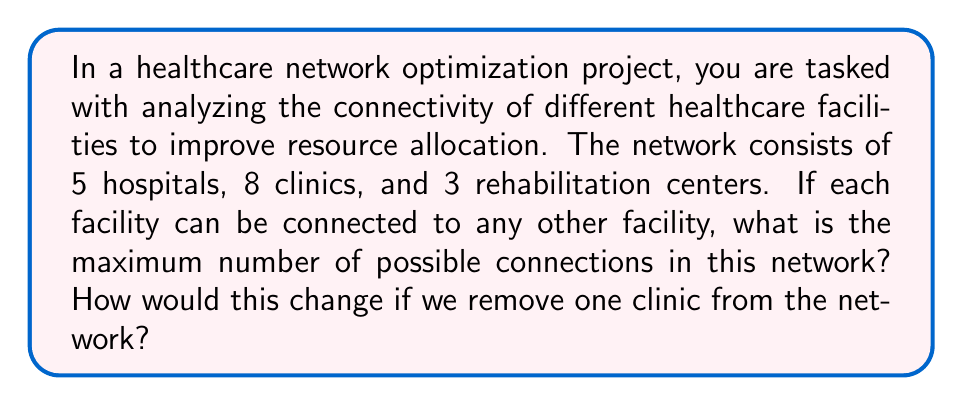Show me your answer to this math problem. To solve this problem, we'll use concepts from graph theory in topology.

1. First, let's calculate the total number of facilities:
   $5 + 8 + 3 = 16$ facilities

2. In a fully connected network, each facility can connect to every other facility except itself. The formula for the maximum number of connections in a network with $n$ nodes is:

   $$\frac{n(n-1)}{2}$$

3. Plugging in our value of $n = 16$:

   $$\frac{16(16-1)}{2} = \frac{16 \times 15}{2} = \frac{240}{2} = 120$$

4. Now, let's consider removing one clinic. This leaves us with 15 facilities:
   $5 + 7 + 3 = 15$ facilities

5. Using the same formula with $n = 15$:

   $$\frac{15(15-1)}{2} = \frac{15 \times 14}{2} = \frac{210}{2} = 105$$

6. To find the difference:
   $120 - 105 = 15$

This means that removing one clinic reduces the maximum number of connections by 15.

Note: In the context of healthcare resource allocation, each connection represents a potential path for sharing resources, patient transfers, or information exchange. Optimizing these connections can lead to more efficient resource utilization and improved patient care coordination.
Answer: The maximum number of possible connections in the original network is 120. After removing one clinic, the maximum number of connections becomes 105, a reduction of 15 connections. 